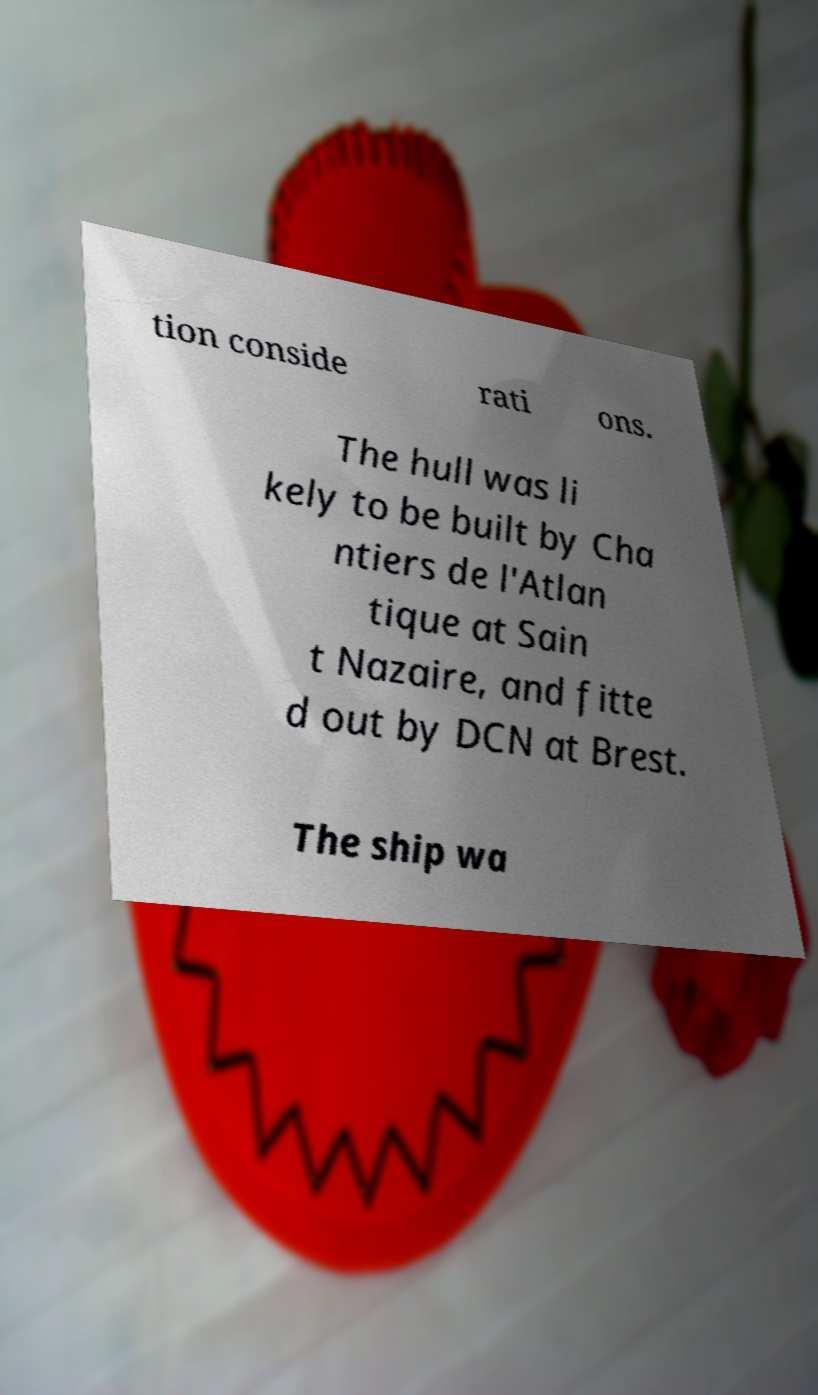Could you assist in decoding the text presented in this image and type it out clearly? tion conside rati ons. The hull was li kely to be built by Cha ntiers de l'Atlan tique at Sain t Nazaire, and fitte d out by DCN at Brest. The ship wa 